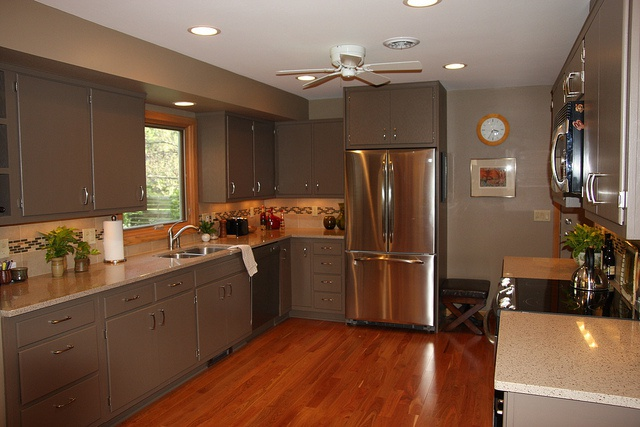Describe the objects in this image and their specific colors. I can see refrigerator in gray, maroon, black, and brown tones, oven in gray, black, maroon, and white tones, microwave in gray, black, and maroon tones, potted plant in gray, black, olive, and maroon tones, and chair in gray, black, and maroon tones in this image. 